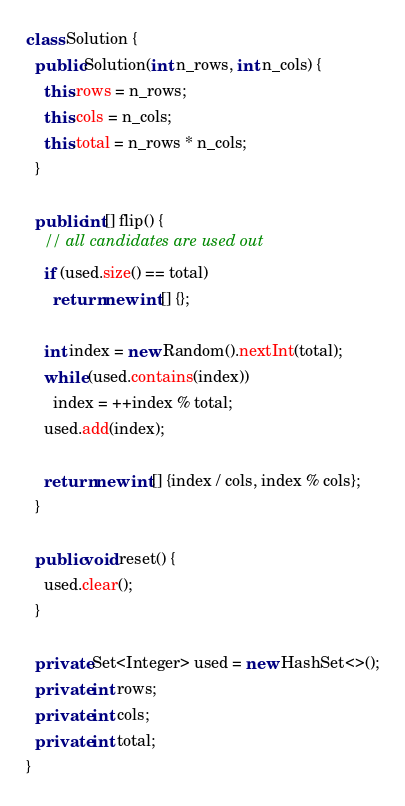Convert code to text. <code><loc_0><loc_0><loc_500><loc_500><_Java_>class Solution {
  public Solution(int n_rows, int n_cols) {
    this.rows = n_rows;
    this.cols = n_cols;
    this.total = n_rows * n_cols;
  }

  public int[] flip() {
    // all candidates are used out
    if (used.size() == total)
      return new int[] {};

    int index = new Random().nextInt(total);
    while (used.contains(index))
      index = ++index % total;
    used.add(index);

    return new int[] {index / cols, index % cols};
  }

  public void reset() {
    used.clear();
  }

  private Set<Integer> used = new HashSet<>();
  private int rows;
  private int cols;
  private int total;
}
</code> 